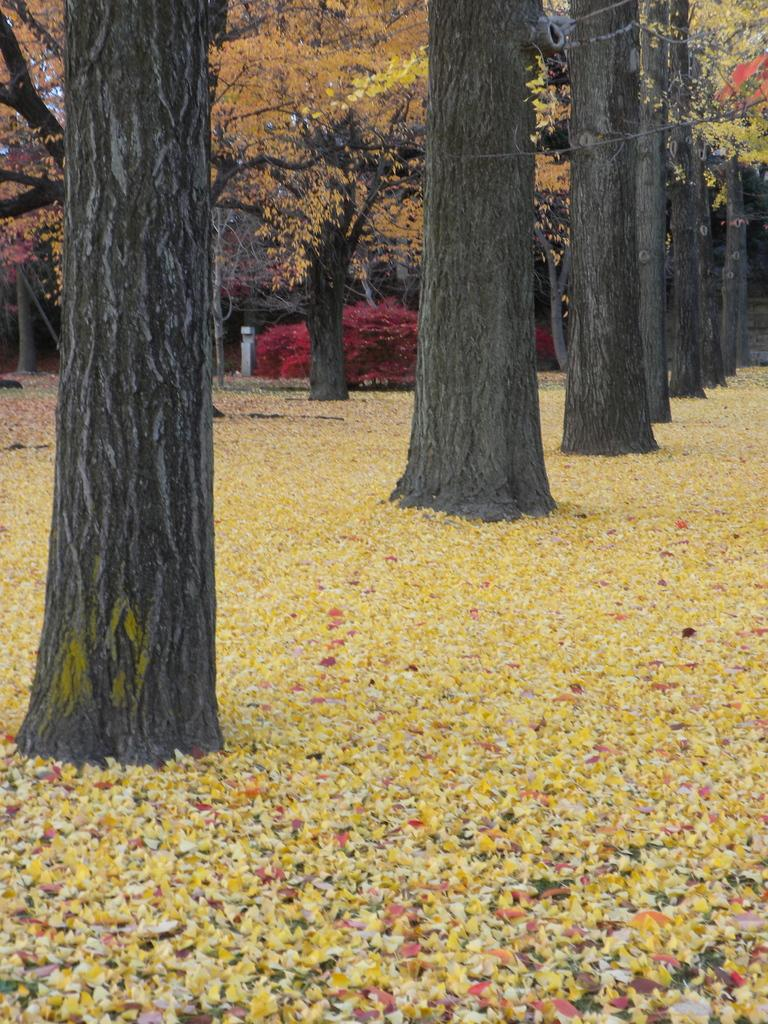What type of vegetation can be seen in the image? There are trees in the image. What is present at the bottom of the image? There are shredded leaves at the bottom of the image. What is the condition of the throat in the image? There is no reference to a throat in the image, as it features trees and shredded leaves. 